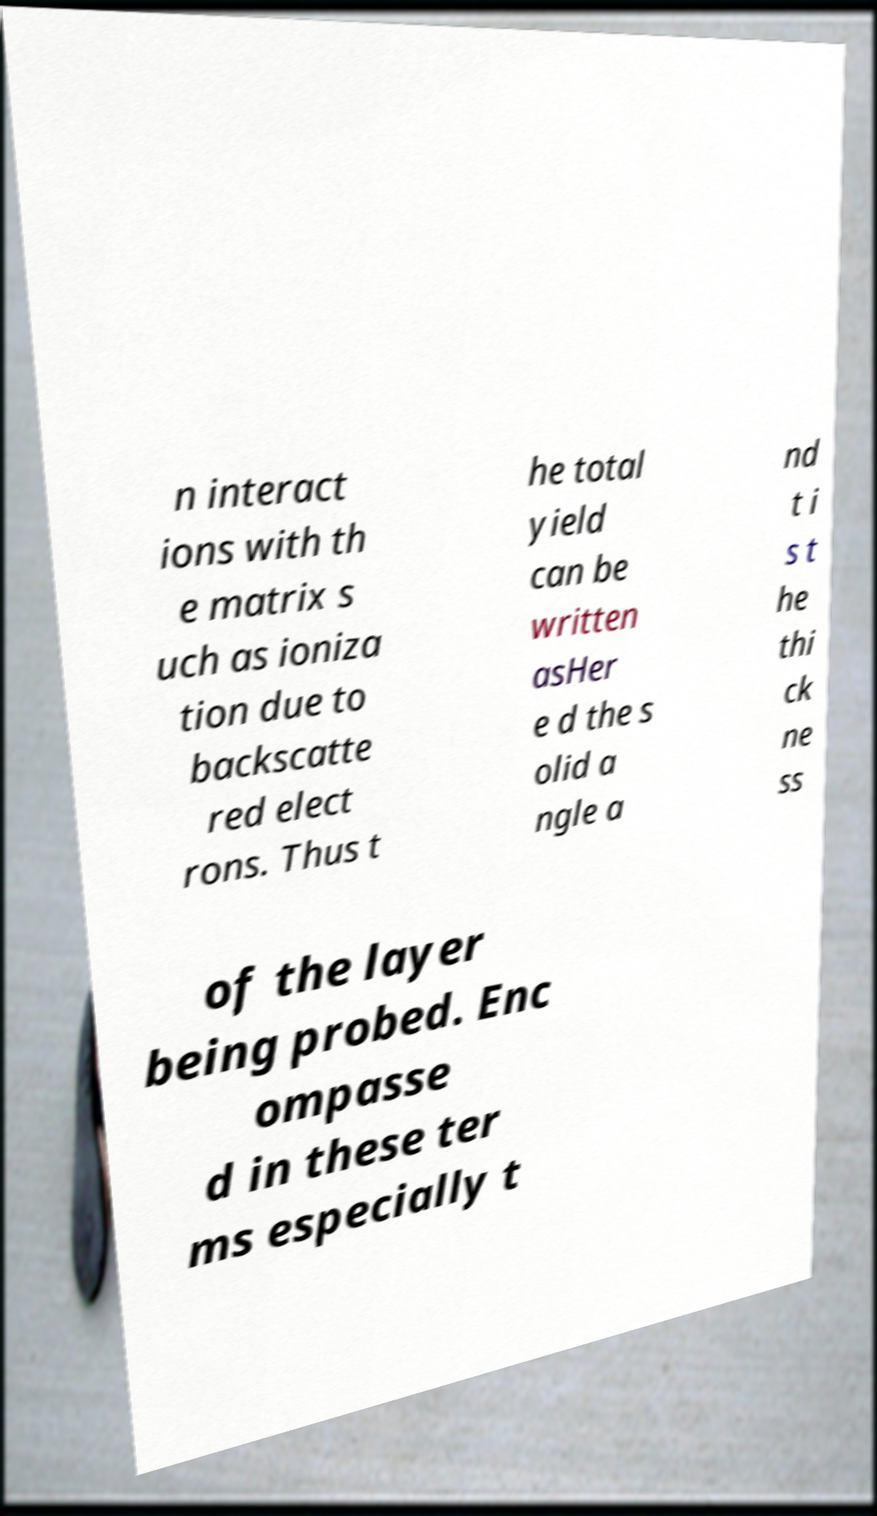There's text embedded in this image that I need extracted. Can you transcribe it verbatim? n interact ions with th e matrix s uch as ioniza tion due to backscatte red elect rons. Thus t he total yield can be written asHer e d the s olid a ngle a nd t i s t he thi ck ne ss of the layer being probed. Enc ompasse d in these ter ms especially t 